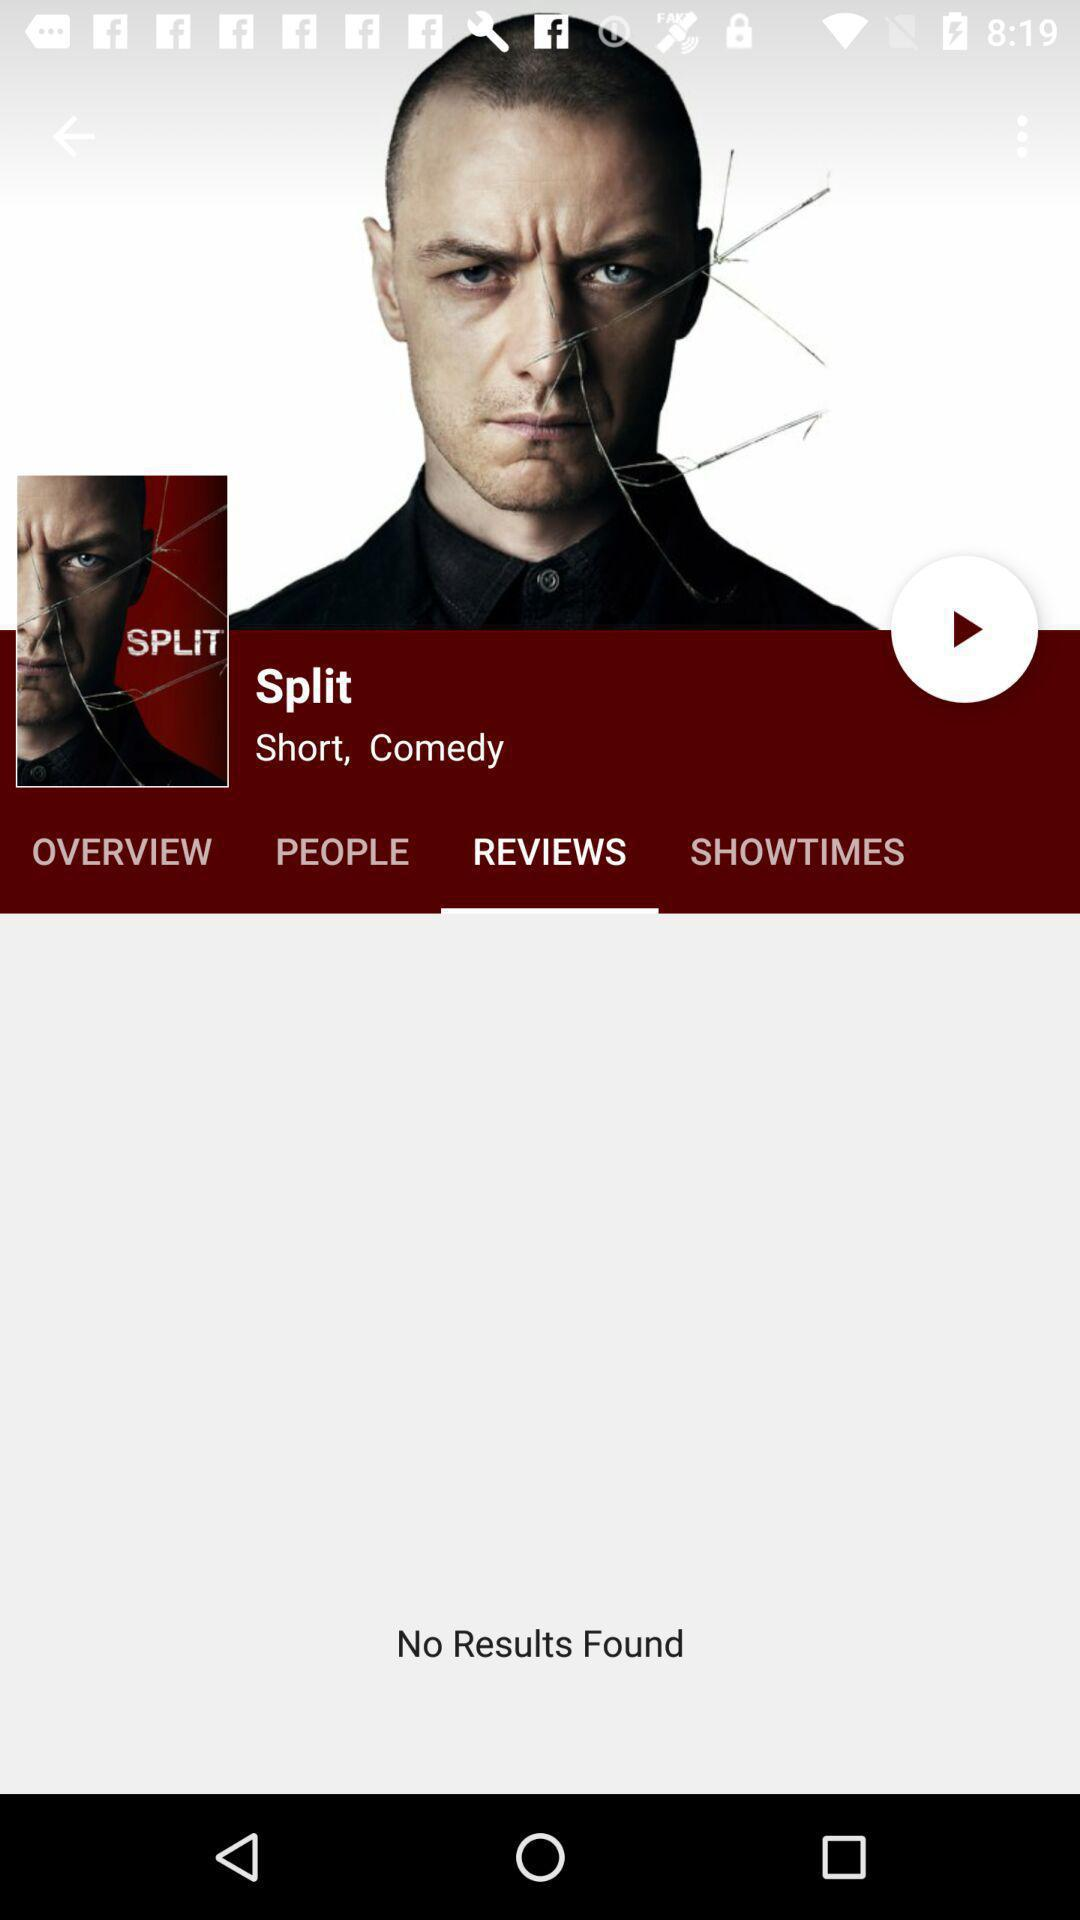Are there any results found for reviews? There is no result found. 